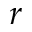<formula> <loc_0><loc_0><loc_500><loc_500>r</formula> 